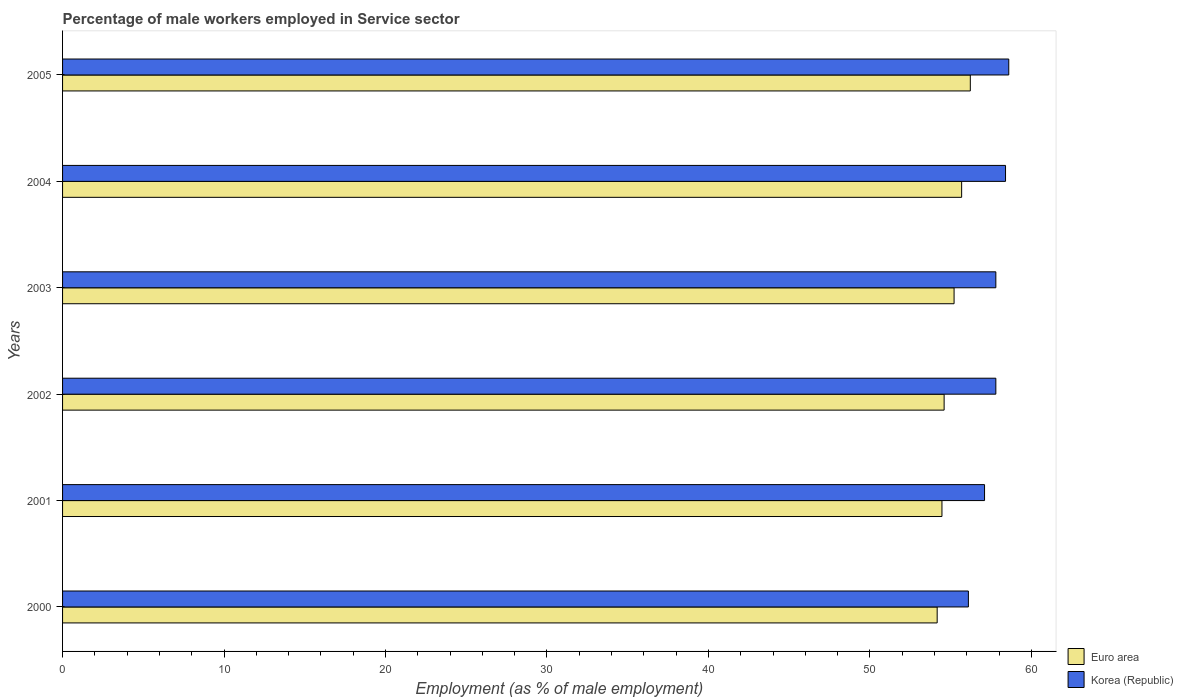How many different coloured bars are there?
Your answer should be compact. 2. How many groups of bars are there?
Offer a very short reply. 6. Are the number of bars per tick equal to the number of legend labels?
Your answer should be compact. Yes. Are the number of bars on each tick of the Y-axis equal?
Your response must be concise. Yes. How many bars are there on the 4th tick from the top?
Give a very brief answer. 2. How many bars are there on the 4th tick from the bottom?
Give a very brief answer. 2. What is the label of the 5th group of bars from the top?
Your answer should be compact. 2001. What is the percentage of male workers employed in Service sector in Euro area in 2005?
Give a very brief answer. 56.22. Across all years, what is the maximum percentage of male workers employed in Service sector in Euro area?
Offer a terse response. 56.22. Across all years, what is the minimum percentage of male workers employed in Service sector in Euro area?
Give a very brief answer. 54.17. In which year was the percentage of male workers employed in Service sector in Euro area minimum?
Provide a succinct answer. 2000. What is the total percentage of male workers employed in Service sector in Korea (Republic) in the graph?
Offer a terse response. 345.8. What is the difference between the percentage of male workers employed in Service sector in Korea (Republic) in 2001 and that in 2004?
Your answer should be very brief. -1.3. What is the difference between the percentage of male workers employed in Service sector in Korea (Republic) in 2004 and the percentage of male workers employed in Service sector in Euro area in 2005?
Your answer should be very brief. 2.18. What is the average percentage of male workers employed in Service sector in Euro area per year?
Make the answer very short. 55.06. In the year 2003, what is the difference between the percentage of male workers employed in Service sector in Korea (Republic) and percentage of male workers employed in Service sector in Euro area?
Your answer should be very brief. 2.59. In how many years, is the percentage of male workers employed in Service sector in Euro area greater than 36 %?
Make the answer very short. 6. What is the ratio of the percentage of male workers employed in Service sector in Korea (Republic) in 2000 to that in 2005?
Offer a terse response. 0.96. What is the difference between the highest and the second highest percentage of male workers employed in Service sector in Euro area?
Offer a very short reply. 0.54. In how many years, is the percentage of male workers employed in Service sector in Korea (Republic) greater than the average percentage of male workers employed in Service sector in Korea (Republic) taken over all years?
Keep it short and to the point. 4. How many years are there in the graph?
Keep it short and to the point. 6. What is the difference between two consecutive major ticks on the X-axis?
Keep it short and to the point. 10. Does the graph contain any zero values?
Keep it short and to the point. No. What is the title of the graph?
Ensure brevity in your answer.  Percentage of male workers employed in Service sector. What is the label or title of the X-axis?
Your response must be concise. Employment (as % of male employment). What is the Employment (as % of male employment) of Euro area in 2000?
Your answer should be very brief. 54.17. What is the Employment (as % of male employment) in Korea (Republic) in 2000?
Your answer should be very brief. 56.1. What is the Employment (as % of male employment) of Euro area in 2001?
Provide a short and direct response. 54.46. What is the Employment (as % of male employment) in Korea (Republic) in 2001?
Provide a succinct answer. 57.1. What is the Employment (as % of male employment) of Euro area in 2002?
Provide a short and direct response. 54.6. What is the Employment (as % of male employment) in Korea (Republic) in 2002?
Make the answer very short. 57.8. What is the Employment (as % of male employment) in Euro area in 2003?
Offer a terse response. 55.21. What is the Employment (as % of male employment) of Korea (Republic) in 2003?
Offer a terse response. 57.8. What is the Employment (as % of male employment) in Euro area in 2004?
Your answer should be compact. 55.68. What is the Employment (as % of male employment) of Korea (Republic) in 2004?
Your answer should be compact. 58.4. What is the Employment (as % of male employment) in Euro area in 2005?
Ensure brevity in your answer.  56.22. What is the Employment (as % of male employment) of Korea (Republic) in 2005?
Give a very brief answer. 58.6. Across all years, what is the maximum Employment (as % of male employment) in Euro area?
Keep it short and to the point. 56.22. Across all years, what is the maximum Employment (as % of male employment) in Korea (Republic)?
Your response must be concise. 58.6. Across all years, what is the minimum Employment (as % of male employment) in Euro area?
Make the answer very short. 54.17. Across all years, what is the minimum Employment (as % of male employment) in Korea (Republic)?
Offer a very short reply. 56.1. What is the total Employment (as % of male employment) in Euro area in the graph?
Ensure brevity in your answer.  330.34. What is the total Employment (as % of male employment) of Korea (Republic) in the graph?
Offer a terse response. 345.8. What is the difference between the Employment (as % of male employment) of Euro area in 2000 and that in 2001?
Keep it short and to the point. -0.3. What is the difference between the Employment (as % of male employment) of Korea (Republic) in 2000 and that in 2001?
Provide a succinct answer. -1. What is the difference between the Employment (as % of male employment) in Euro area in 2000 and that in 2002?
Make the answer very short. -0.43. What is the difference between the Employment (as % of male employment) in Euro area in 2000 and that in 2003?
Your answer should be compact. -1.05. What is the difference between the Employment (as % of male employment) of Korea (Republic) in 2000 and that in 2003?
Offer a very short reply. -1.7. What is the difference between the Employment (as % of male employment) of Euro area in 2000 and that in 2004?
Provide a short and direct response. -1.52. What is the difference between the Employment (as % of male employment) in Korea (Republic) in 2000 and that in 2004?
Your response must be concise. -2.3. What is the difference between the Employment (as % of male employment) of Euro area in 2000 and that in 2005?
Offer a terse response. -2.05. What is the difference between the Employment (as % of male employment) in Korea (Republic) in 2000 and that in 2005?
Ensure brevity in your answer.  -2.5. What is the difference between the Employment (as % of male employment) of Euro area in 2001 and that in 2002?
Keep it short and to the point. -0.13. What is the difference between the Employment (as % of male employment) of Euro area in 2001 and that in 2003?
Give a very brief answer. -0.75. What is the difference between the Employment (as % of male employment) of Euro area in 2001 and that in 2004?
Provide a succinct answer. -1.22. What is the difference between the Employment (as % of male employment) of Euro area in 2001 and that in 2005?
Your answer should be compact. -1.76. What is the difference between the Employment (as % of male employment) of Korea (Republic) in 2001 and that in 2005?
Provide a succinct answer. -1.5. What is the difference between the Employment (as % of male employment) in Euro area in 2002 and that in 2003?
Your answer should be compact. -0.62. What is the difference between the Employment (as % of male employment) in Euro area in 2002 and that in 2004?
Ensure brevity in your answer.  -1.09. What is the difference between the Employment (as % of male employment) in Euro area in 2002 and that in 2005?
Provide a succinct answer. -1.62. What is the difference between the Employment (as % of male employment) in Euro area in 2003 and that in 2004?
Your response must be concise. -0.47. What is the difference between the Employment (as % of male employment) of Korea (Republic) in 2003 and that in 2004?
Make the answer very short. -0.6. What is the difference between the Employment (as % of male employment) in Euro area in 2003 and that in 2005?
Your answer should be compact. -1.01. What is the difference between the Employment (as % of male employment) in Euro area in 2004 and that in 2005?
Keep it short and to the point. -0.54. What is the difference between the Employment (as % of male employment) in Euro area in 2000 and the Employment (as % of male employment) in Korea (Republic) in 2001?
Your response must be concise. -2.93. What is the difference between the Employment (as % of male employment) of Euro area in 2000 and the Employment (as % of male employment) of Korea (Republic) in 2002?
Keep it short and to the point. -3.63. What is the difference between the Employment (as % of male employment) in Euro area in 2000 and the Employment (as % of male employment) in Korea (Republic) in 2003?
Provide a short and direct response. -3.63. What is the difference between the Employment (as % of male employment) in Euro area in 2000 and the Employment (as % of male employment) in Korea (Republic) in 2004?
Give a very brief answer. -4.23. What is the difference between the Employment (as % of male employment) of Euro area in 2000 and the Employment (as % of male employment) of Korea (Republic) in 2005?
Offer a terse response. -4.43. What is the difference between the Employment (as % of male employment) of Euro area in 2001 and the Employment (as % of male employment) of Korea (Republic) in 2002?
Your answer should be compact. -3.34. What is the difference between the Employment (as % of male employment) of Euro area in 2001 and the Employment (as % of male employment) of Korea (Republic) in 2003?
Ensure brevity in your answer.  -3.34. What is the difference between the Employment (as % of male employment) in Euro area in 2001 and the Employment (as % of male employment) in Korea (Republic) in 2004?
Your response must be concise. -3.94. What is the difference between the Employment (as % of male employment) in Euro area in 2001 and the Employment (as % of male employment) in Korea (Republic) in 2005?
Your response must be concise. -4.14. What is the difference between the Employment (as % of male employment) in Euro area in 2002 and the Employment (as % of male employment) in Korea (Republic) in 2003?
Provide a succinct answer. -3.2. What is the difference between the Employment (as % of male employment) in Euro area in 2002 and the Employment (as % of male employment) in Korea (Republic) in 2004?
Your answer should be very brief. -3.8. What is the difference between the Employment (as % of male employment) of Euro area in 2002 and the Employment (as % of male employment) of Korea (Republic) in 2005?
Your response must be concise. -4. What is the difference between the Employment (as % of male employment) in Euro area in 2003 and the Employment (as % of male employment) in Korea (Republic) in 2004?
Provide a short and direct response. -3.19. What is the difference between the Employment (as % of male employment) in Euro area in 2003 and the Employment (as % of male employment) in Korea (Republic) in 2005?
Ensure brevity in your answer.  -3.39. What is the difference between the Employment (as % of male employment) of Euro area in 2004 and the Employment (as % of male employment) of Korea (Republic) in 2005?
Give a very brief answer. -2.92. What is the average Employment (as % of male employment) of Euro area per year?
Keep it short and to the point. 55.06. What is the average Employment (as % of male employment) in Korea (Republic) per year?
Offer a very short reply. 57.63. In the year 2000, what is the difference between the Employment (as % of male employment) of Euro area and Employment (as % of male employment) of Korea (Republic)?
Provide a succinct answer. -1.93. In the year 2001, what is the difference between the Employment (as % of male employment) in Euro area and Employment (as % of male employment) in Korea (Republic)?
Offer a very short reply. -2.64. In the year 2002, what is the difference between the Employment (as % of male employment) in Euro area and Employment (as % of male employment) in Korea (Republic)?
Provide a succinct answer. -3.2. In the year 2003, what is the difference between the Employment (as % of male employment) of Euro area and Employment (as % of male employment) of Korea (Republic)?
Give a very brief answer. -2.59. In the year 2004, what is the difference between the Employment (as % of male employment) of Euro area and Employment (as % of male employment) of Korea (Republic)?
Keep it short and to the point. -2.72. In the year 2005, what is the difference between the Employment (as % of male employment) in Euro area and Employment (as % of male employment) in Korea (Republic)?
Offer a terse response. -2.38. What is the ratio of the Employment (as % of male employment) in Korea (Republic) in 2000 to that in 2001?
Your response must be concise. 0.98. What is the ratio of the Employment (as % of male employment) of Korea (Republic) in 2000 to that in 2002?
Provide a succinct answer. 0.97. What is the ratio of the Employment (as % of male employment) of Korea (Republic) in 2000 to that in 2003?
Offer a very short reply. 0.97. What is the ratio of the Employment (as % of male employment) in Euro area in 2000 to that in 2004?
Provide a short and direct response. 0.97. What is the ratio of the Employment (as % of male employment) in Korea (Republic) in 2000 to that in 2004?
Provide a succinct answer. 0.96. What is the ratio of the Employment (as % of male employment) of Euro area in 2000 to that in 2005?
Keep it short and to the point. 0.96. What is the ratio of the Employment (as % of male employment) of Korea (Republic) in 2000 to that in 2005?
Offer a very short reply. 0.96. What is the ratio of the Employment (as % of male employment) of Korea (Republic) in 2001 to that in 2002?
Your response must be concise. 0.99. What is the ratio of the Employment (as % of male employment) in Euro area in 2001 to that in 2003?
Your answer should be very brief. 0.99. What is the ratio of the Employment (as % of male employment) of Korea (Republic) in 2001 to that in 2003?
Offer a terse response. 0.99. What is the ratio of the Employment (as % of male employment) in Euro area in 2001 to that in 2004?
Give a very brief answer. 0.98. What is the ratio of the Employment (as % of male employment) of Korea (Republic) in 2001 to that in 2004?
Give a very brief answer. 0.98. What is the ratio of the Employment (as % of male employment) of Euro area in 2001 to that in 2005?
Your answer should be very brief. 0.97. What is the ratio of the Employment (as % of male employment) in Korea (Republic) in 2001 to that in 2005?
Offer a terse response. 0.97. What is the ratio of the Employment (as % of male employment) in Euro area in 2002 to that in 2004?
Ensure brevity in your answer.  0.98. What is the ratio of the Employment (as % of male employment) in Euro area in 2002 to that in 2005?
Your answer should be very brief. 0.97. What is the ratio of the Employment (as % of male employment) in Korea (Republic) in 2002 to that in 2005?
Provide a short and direct response. 0.99. What is the ratio of the Employment (as % of male employment) of Korea (Republic) in 2003 to that in 2004?
Your response must be concise. 0.99. What is the ratio of the Employment (as % of male employment) in Euro area in 2003 to that in 2005?
Your answer should be compact. 0.98. What is the ratio of the Employment (as % of male employment) of Korea (Republic) in 2003 to that in 2005?
Offer a terse response. 0.99. What is the difference between the highest and the second highest Employment (as % of male employment) in Euro area?
Your response must be concise. 0.54. What is the difference between the highest and the second highest Employment (as % of male employment) in Korea (Republic)?
Provide a short and direct response. 0.2. What is the difference between the highest and the lowest Employment (as % of male employment) of Euro area?
Offer a terse response. 2.05. What is the difference between the highest and the lowest Employment (as % of male employment) of Korea (Republic)?
Offer a terse response. 2.5. 